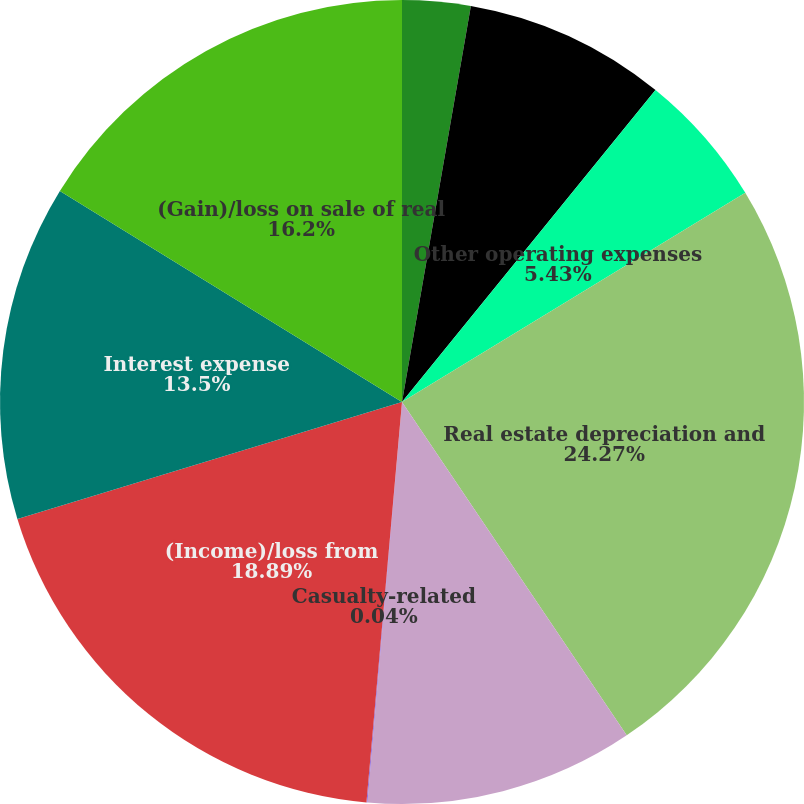<chart> <loc_0><loc_0><loc_500><loc_500><pie_chart><fcel>Net income/(loss) attributable<fcel>Property management<fcel>Other operating expenses<fcel>Real estate depreciation and<fcel>General and administrative<fcel>Casualty-related<fcel>(Income)/loss from<fcel>Interest expense<fcel>(Gain)/loss on sale of real<nl><fcel>2.74%<fcel>8.12%<fcel>5.43%<fcel>24.27%<fcel>10.81%<fcel>0.04%<fcel>18.89%<fcel>13.5%<fcel>16.2%<nl></chart> 